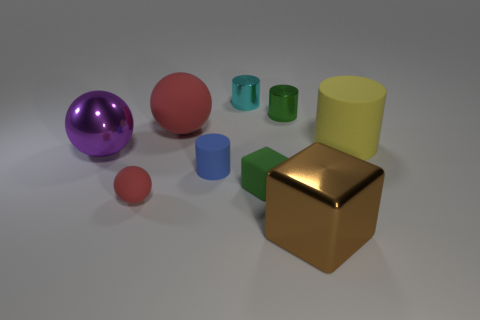There is a red thing behind the large purple shiny sphere; what is its size?
Your answer should be compact. Large. There is a purple object that is made of the same material as the tiny green cylinder; what is its shape?
Your response must be concise. Sphere. Is there anything else that has the same color as the matte cube?
Give a very brief answer. Yes. The cylinder that is in front of the large matte thing on the right side of the big brown block is what color?
Your answer should be very brief. Blue. What number of tiny things are either gray shiny cylinders or cyan cylinders?
Offer a very short reply. 1. There is a big thing that is the same shape as the tiny cyan metallic thing; what material is it?
Your answer should be very brief. Rubber. Are there any other things that are made of the same material as the brown thing?
Ensure brevity in your answer.  Yes. The small matte cylinder is what color?
Offer a very short reply. Blue. Is the color of the tiny sphere the same as the big matte sphere?
Offer a terse response. Yes. How many yellow matte things are on the right side of the big metallic object that is right of the tiny ball?
Provide a short and direct response. 1. 